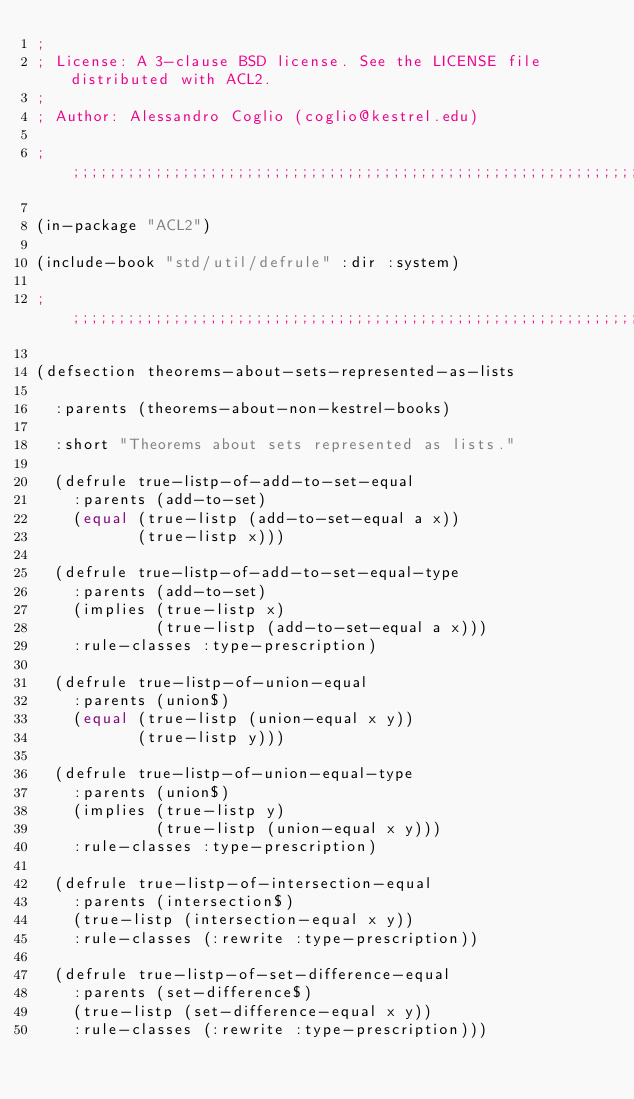<code> <loc_0><loc_0><loc_500><loc_500><_Lisp_>;
; License: A 3-clause BSD license. See the LICENSE file distributed with ACL2.
;
; Author: Alessandro Coglio (coglio@kestrel.edu)

;;;;;;;;;;;;;;;;;;;;;;;;;;;;;;;;;;;;;;;;;;;;;;;;;;;;;;;;;;;;;;;;;;;;;;;;;;;;;;;;

(in-package "ACL2")

(include-book "std/util/defrule" :dir :system)

;;;;;;;;;;;;;;;;;;;;;;;;;;;;;;;;;;;;;;;;;;;;;;;;;;;;;;;;;;;;;;;;;;;;;;;;;;;;;;;;

(defsection theorems-about-sets-represented-as-lists

  :parents (theorems-about-non-kestrel-books)

  :short "Theorems about sets represented as lists."

  (defrule true-listp-of-add-to-set-equal
    :parents (add-to-set)
    (equal (true-listp (add-to-set-equal a x))
           (true-listp x)))

  (defrule true-listp-of-add-to-set-equal-type
    :parents (add-to-set)
    (implies (true-listp x)
             (true-listp (add-to-set-equal a x)))
    :rule-classes :type-prescription)

  (defrule true-listp-of-union-equal
    :parents (union$)
    (equal (true-listp (union-equal x y))
           (true-listp y)))

  (defrule true-listp-of-union-equal-type
    :parents (union$)
    (implies (true-listp y)
             (true-listp (union-equal x y)))
    :rule-classes :type-prescription)

  (defrule true-listp-of-intersection-equal
    :parents (intersection$)
    (true-listp (intersection-equal x y))
    :rule-classes (:rewrite :type-prescription))

  (defrule true-listp-of-set-difference-equal
    :parents (set-difference$)
    (true-listp (set-difference-equal x y))
    :rule-classes (:rewrite :type-prescription)))
</code> 